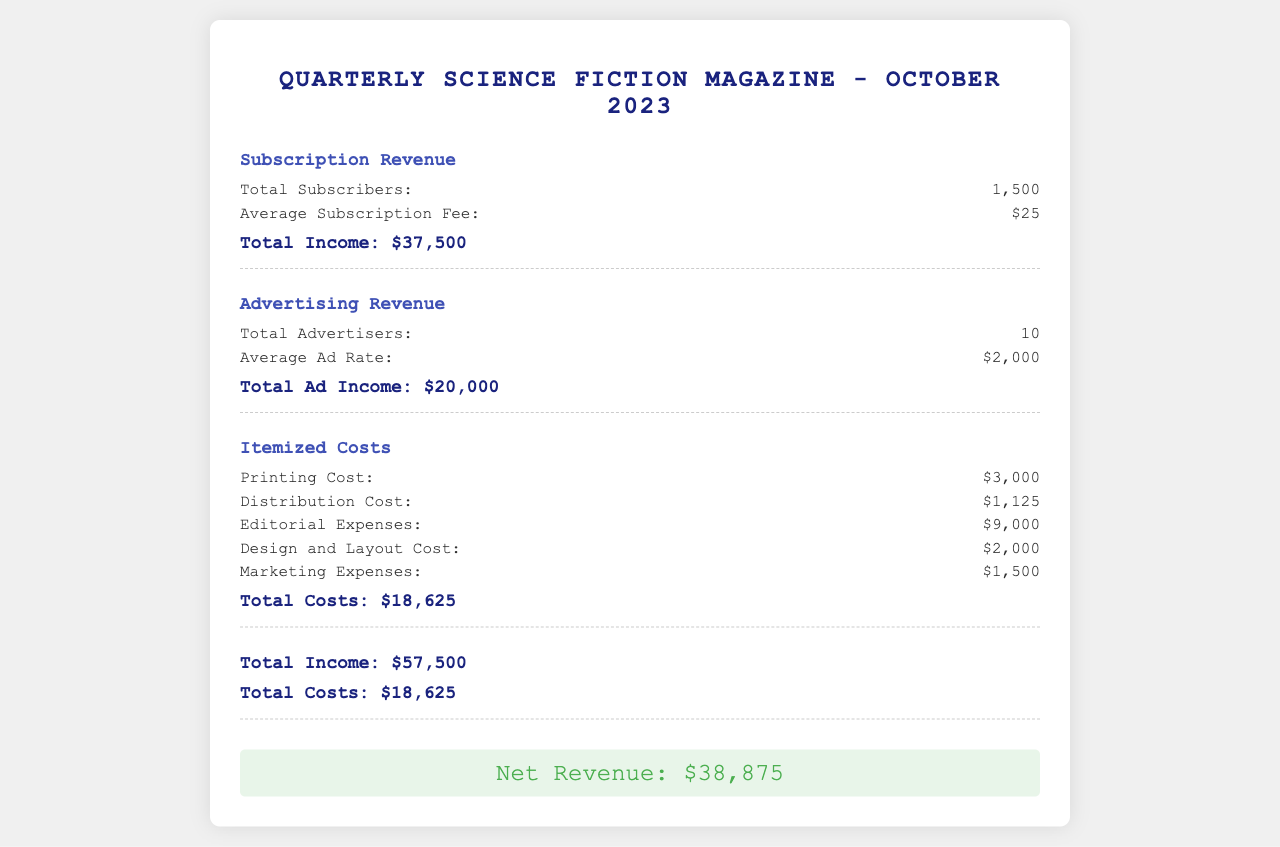What is the total number of subscribers? The total number of subscribers is explicitly stated in the subscription revenue section.
Answer: 1,500 What is the average subscription fee? The average subscription fee can be found in the subscription revenue section.
Answer: $25 What is the total ad income? The total ad income is the sum derived from the number of advertisers and the average ad rate in the advertising revenue section.
Answer: $20,000 What is the total cost of printing? The cost of printing is listed in the itemized costs section of the document.
Answer: $3,000 What are the total itemized costs? The total itemized costs are calculated and presented at the end of the itemized costs section.
Answer: $18,625 What is the net revenue? The net revenue is displayed prominently after calculating total income and total costs.
Answer: $38,875 How many advertisers are mentioned? The document states the total number of advertisers in the advertising revenue section.
Answer: 10 What is the total income from subscriptions and advertising combined? The document presents the total income combining subscriptions and advertising revenues.
Answer: $57,500 What is the design and layout cost? The design and layout cost is specifically stated in the itemized costs section.
Answer: $2,000 